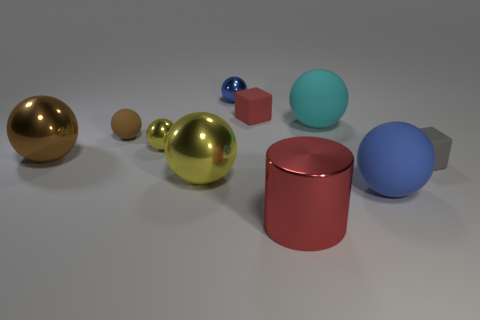Subtract 1 spheres. How many spheres are left? 6 Subtract all blue spheres. How many spheres are left? 5 Subtract all brown shiny spheres. How many spheres are left? 6 Subtract all red balls. Subtract all purple cylinders. How many balls are left? 7 Subtract all spheres. How many objects are left? 3 Add 9 big blue rubber balls. How many big blue rubber balls are left? 10 Add 6 small red matte cubes. How many small red matte cubes exist? 7 Subtract 0 blue blocks. How many objects are left? 10 Subtract all small red rubber objects. Subtract all gray rubber blocks. How many objects are left? 8 